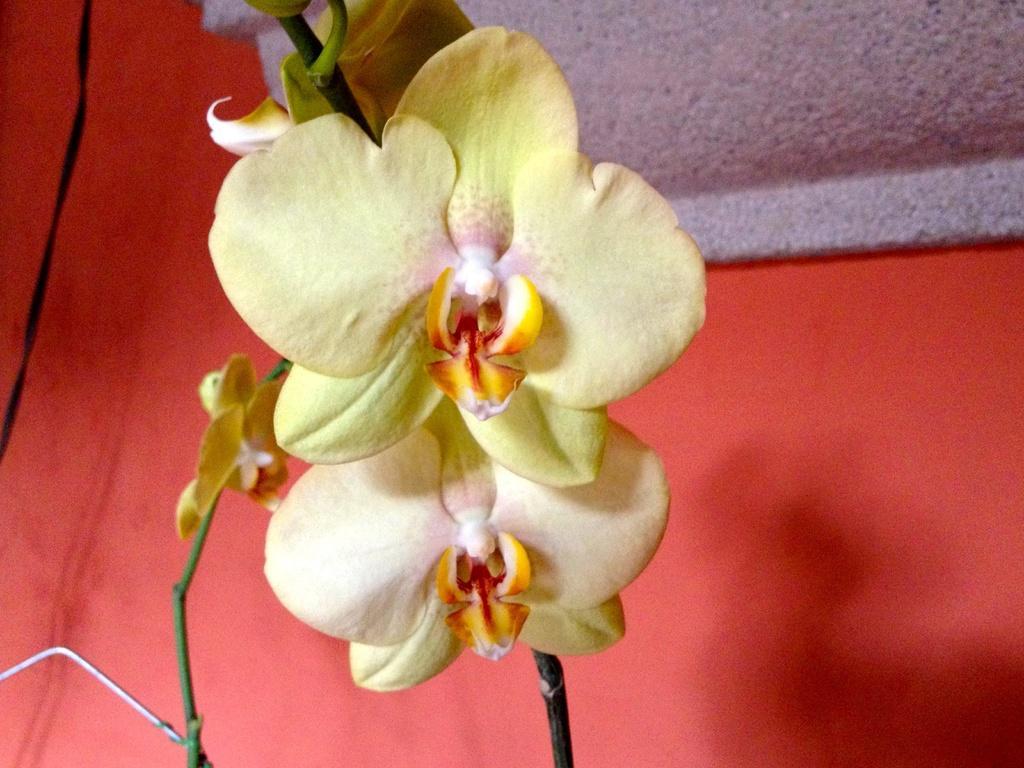Can you describe this image briefly? In this image in the foreground there is one flower, and in the background there is a wall. 